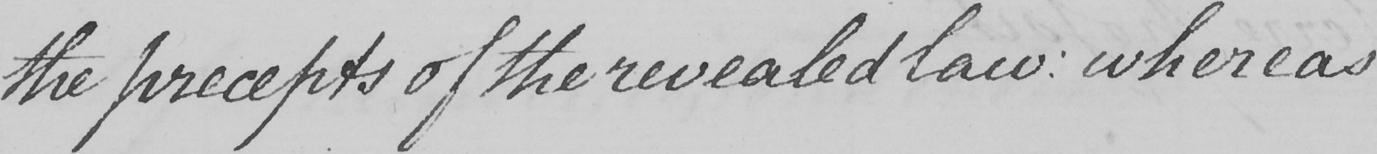Can you tell me what this handwritten text says? the precepts of the revealed law :  whereas 